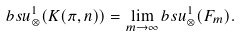Convert formula to latex. <formula><loc_0><loc_0><loc_500><loc_500>b s u _ { \otimes } ^ { 1 } ( K ( \pi , n ) ) = \lim _ { m \to \infty } b s u _ { \otimes } ^ { 1 } ( F _ { m } ) .</formula> 